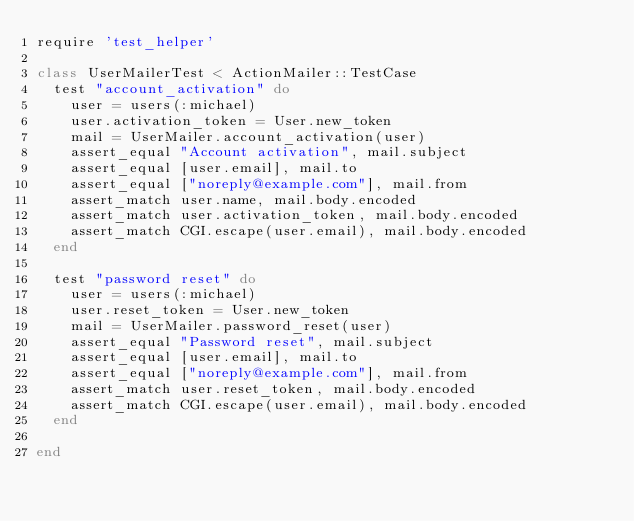<code> <loc_0><loc_0><loc_500><loc_500><_Ruby_>require 'test_helper'

class UserMailerTest < ActionMailer::TestCase
  test "account_activation" do
    user = users(:michael)
    user.activation_token = User.new_token
    mail = UserMailer.account_activation(user)
    assert_equal "Account activation", mail.subject
    assert_equal [user.email], mail.to
    assert_equal ["noreply@example.com"], mail.from
    assert_match user.name, mail.body.encoded
    assert_match user.activation_token, mail.body.encoded
    assert_match CGI.escape(user.email), mail.body.encoded
  end

  test "password reset" do
    user = users(:michael)
    user.reset_token = User.new_token
    mail = UserMailer.password_reset(user)
    assert_equal "Password reset", mail.subject
    assert_equal [user.email], mail.to
    assert_equal ["noreply@example.com"], mail.from
    assert_match user.reset_token, mail.body.encoded
    assert_match CGI.escape(user.email), mail.body.encoded
  end

end
</code> 